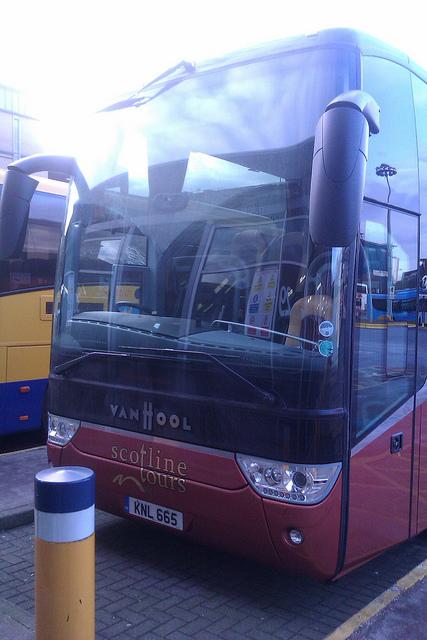Are the bus doors open?
Write a very short answer. No. What is the license plate number?
Give a very brief answer. Kml 665. Is this a US license plate?
Concise answer only. No. 